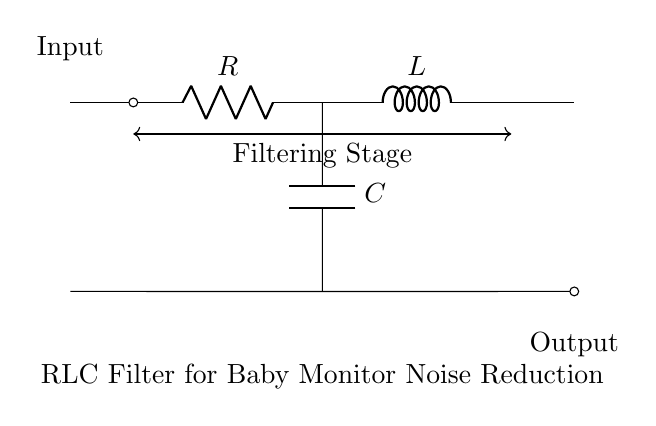What components are present in this circuit? The circuit consists of a resistor, an inductor, and a capacitor, which can be identified from their symbols labeled as R, L, and C in the diagram.
Answer: Resistor, Inductor, Capacitor What is the function of the RLC filter in this circuit? The RLC filter is designed for noise reduction, as indicated by the label in the diagram. It works by filtering out unwanted frequencies while allowing desired signals to pass through.
Answer: Noise reduction What types of signals does this filter affect? The RLC filter primarily affects alternating current signals, particularly those with high-frequency noise components that may be present in baby monitor audio.
Answer: Alternating current Why is the arrangement of the RLC components important? The arrangement is crucial because the combination of the resistor, inductor, and capacitor determines the filter's cutoff frequency and overall response characteristics, which are essential for effective noise reduction.
Answer: Cutoff frequency What is the role of the capacitor in this RLC circuit? The capacitor stores and releases electrical energy, and it plays a vital role in determining the frequency response of the filter, specifically filtering high-frequency noise signals.
Answer: Energy storage What does the arrow represent in the circuit? The arrow indicates the flow of the input signal entering the circuit and the output signal exiting after undergoing filtering through the RLC components.
Answer: Input and output signal flow 